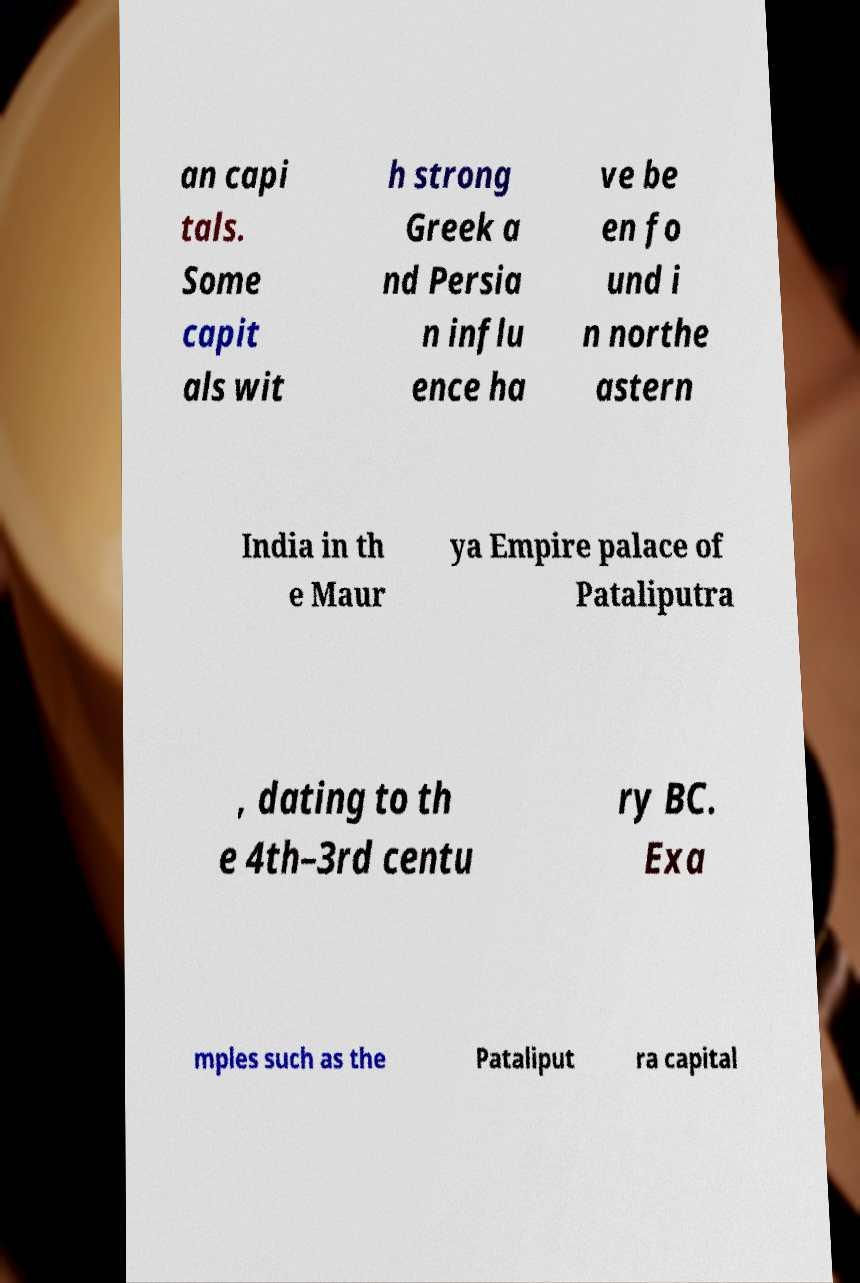Please identify and transcribe the text found in this image. an capi tals. Some capit als wit h strong Greek a nd Persia n influ ence ha ve be en fo und i n northe astern India in th e Maur ya Empire palace of Pataliputra , dating to th e 4th–3rd centu ry BC. Exa mples such as the Pataliput ra capital 